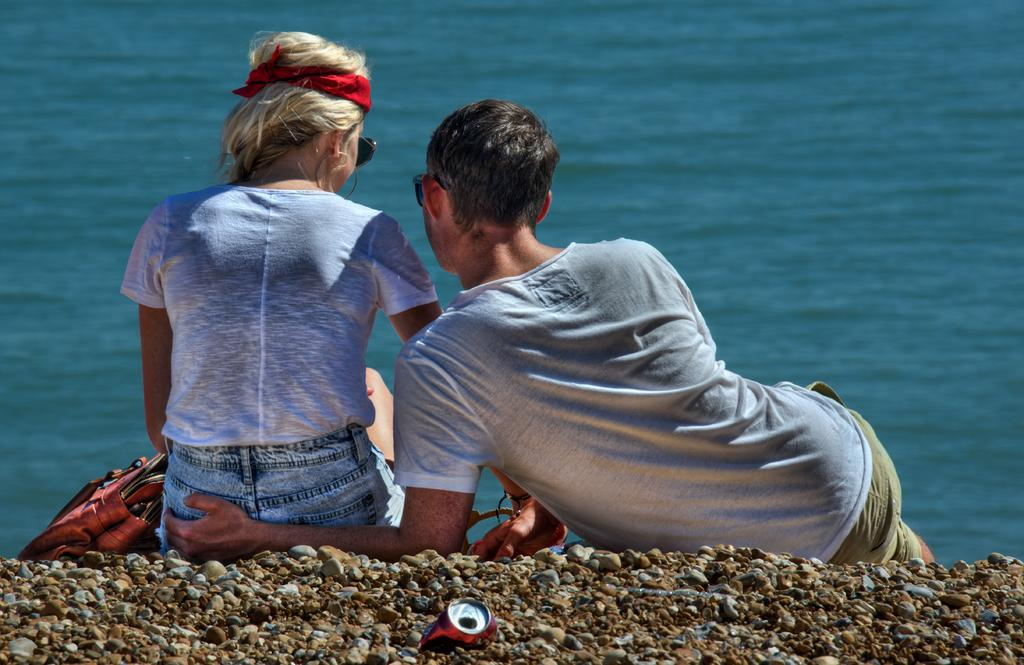How many people are sitting in the image? There are two people sitting in the image. Where are the people sitting? The people are sitting near a lake. What object can be seen on the surface in the image? There is a handbag on the surface in the image. What natural feature is visible in the image? There is a lake visible in the image. What type of terrain is present in the image? There are stones present in the image. What type of pipe can be seen in the image? There is no pipe present in the image. What is the reaction of the people when they receive a surprise in the image? There is no indication of a surprise or any reaction in the image. 